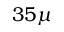<formula> <loc_0><loc_0><loc_500><loc_500>3 5 \mu</formula> 